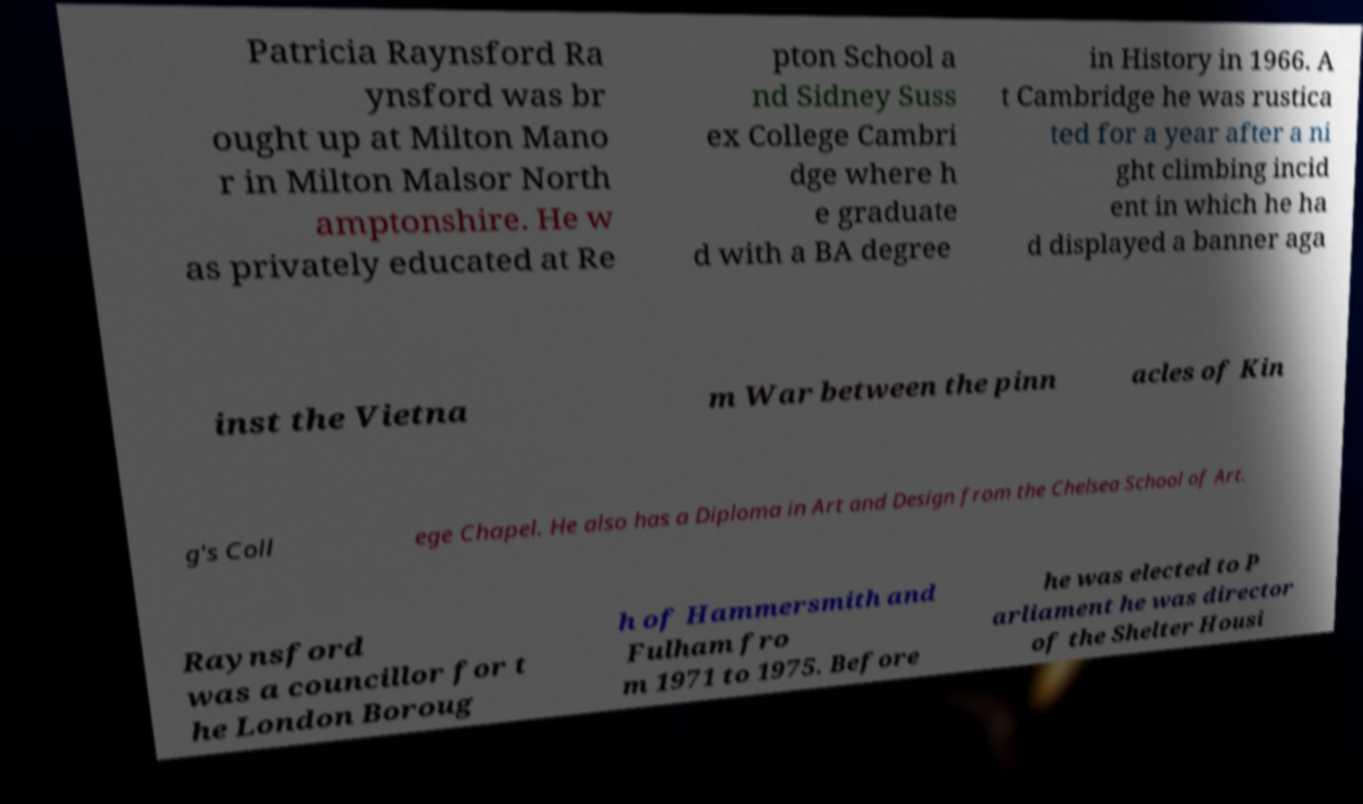What messages or text are displayed in this image? I need them in a readable, typed format. Patricia Raynsford Ra ynsford was br ought up at Milton Mano r in Milton Malsor North amptonshire. He w as privately educated at Re pton School a nd Sidney Suss ex College Cambri dge where h e graduate d with a BA degree in History in 1966. A t Cambridge he was rustica ted for a year after a ni ght climbing incid ent in which he ha d displayed a banner aga inst the Vietna m War between the pinn acles of Kin g's Coll ege Chapel. He also has a Diploma in Art and Design from the Chelsea School of Art. Raynsford was a councillor for t he London Boroug h of Hammersmith and Fulham fro m 1971 to 1975. Before he was elected to P arliament he was director of the Shelter Housi 